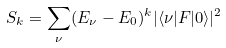Convert formula to latex. <formula><loc_0><loc_0><loc_500><loc_500>S _ { k } = \sum _ { \nu } ( E _ { \nu } - E _ { 0 } ) ^ { k } | \langle \nu | F | 0 \rangle | ^ { 2 }</formula> 